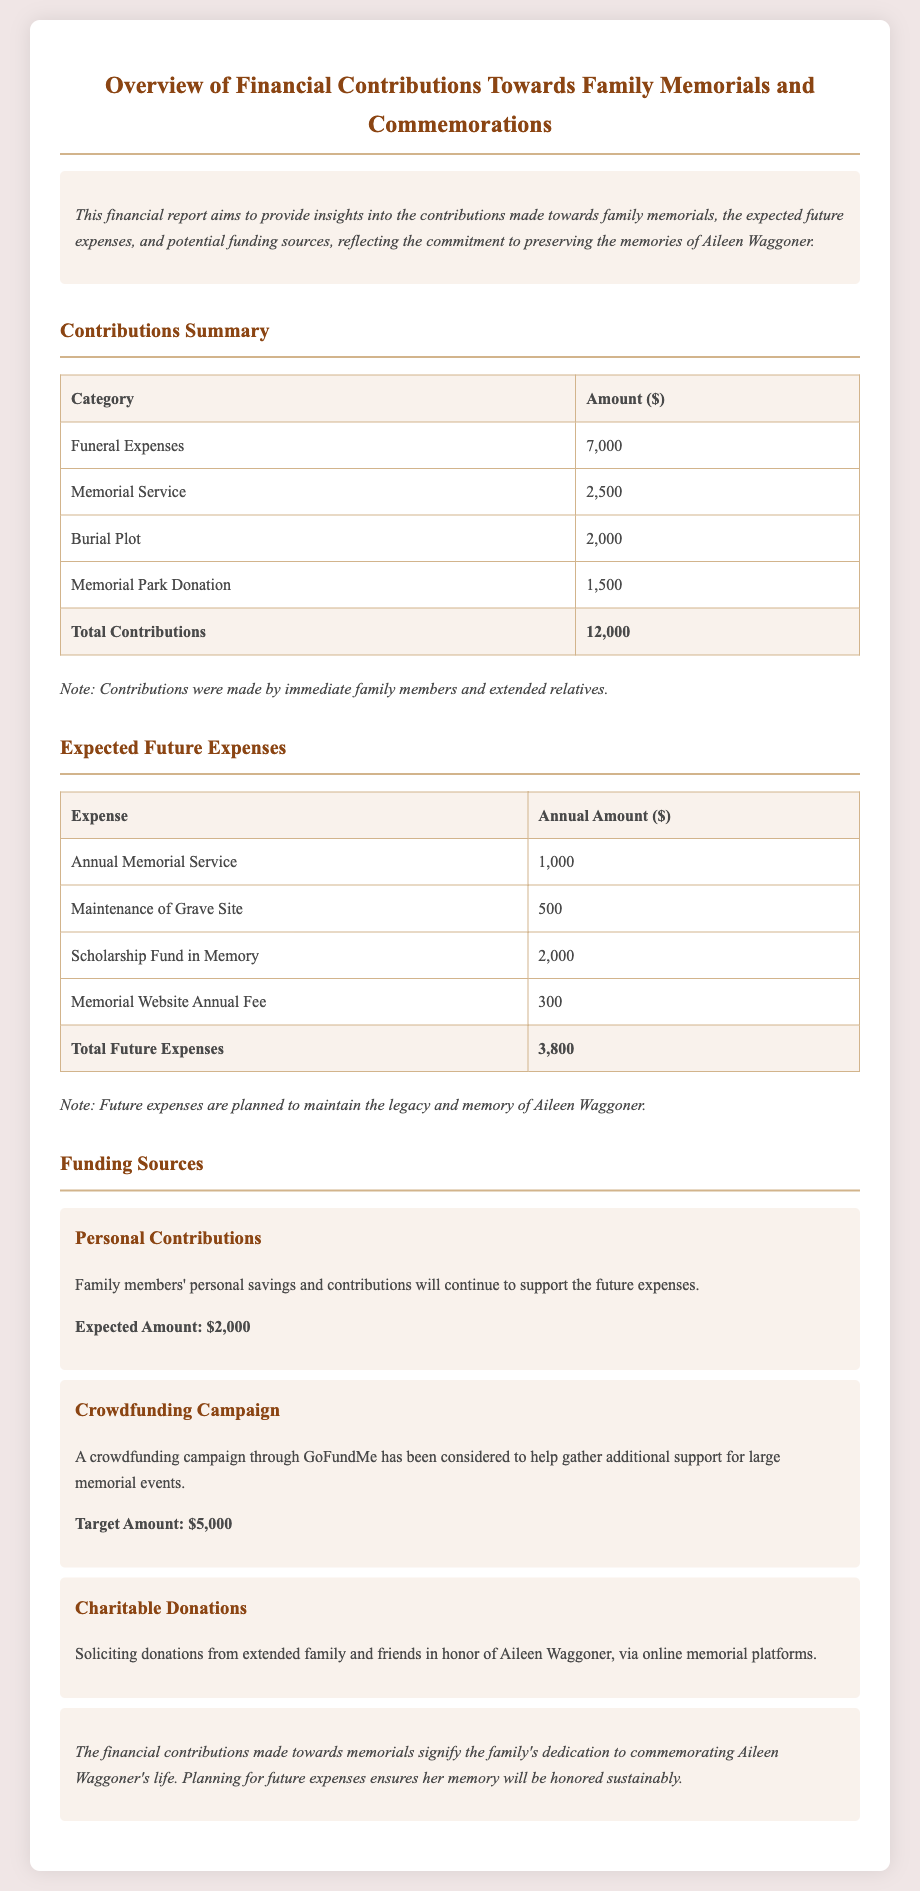What was the total amount contributed towards memorials? The total contributions are listed at the end of the contributions summary, which is $12,000.
Answer: $12,000 How much is expected for the annual memorial service? The expected amount for the annual memorial service is stated in the future expenses section, which is $1,000.
Answer: $1,000 What is the target amount for the crowdfunding campaign? The target amount for the crowdfunding campaign is mentioned under funding sources, which is $5,000.
Answer: $5,000 What is the total amount expected for future expenses? The total future expenses are provided in the table, summing up to $3,800.
Answer: $3,800 What category has the highest contribution? The category with the highest contribution is noted in the contributions summary table, which is "Funeral Expenses" at $7,000.
Answer: Funeral Expenses How much is allocated for the scholarship fund? The document states that the annual amount allocated for the scholarship fund in memory is $2,000 under expected future expenses.
Answer: $2,000 What type of donations are solicited from friends and family? The document specifies that charitable donations are solicited in honor of Aileen Waggoner through online memorial platforms.
Answer: Charitable donations What is the amount planned for grave site maintenance annually? The annual amount for the maintenance of the grave site is listed as $500 in the future expenses section.
Answer: $500 What note is provided regarding contributions? The note mentions that contributions were made by immediate family members and extended relatives.
Answer: Immediate family members and extended relatives 